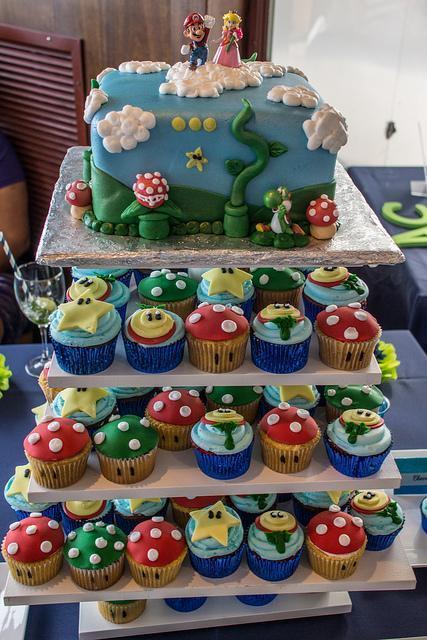How many layers are there?
Give a very brief answer. 5. How many people can you see?
Give a very brief answer. 1. How many cakes are there?
Give a very brief answer. 11. 